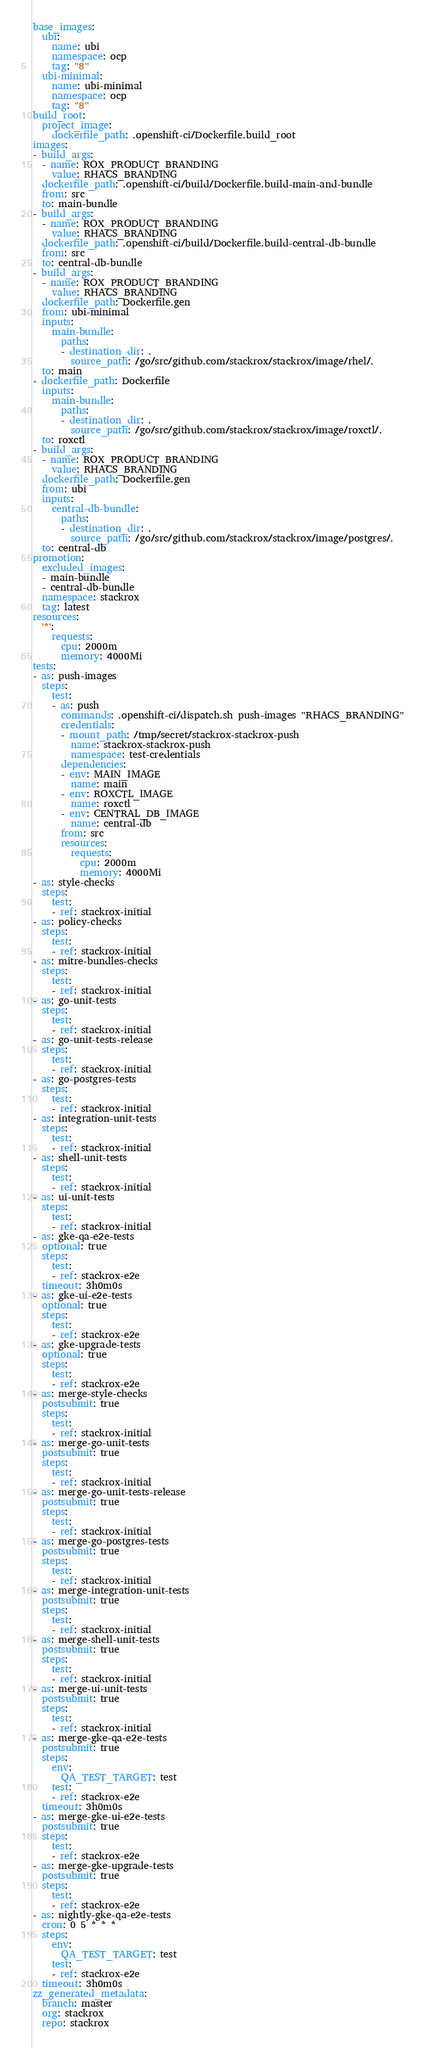Convert code to text. <code><loc_0><loc_0><loc_500><loc_500><_YAML_>base_images:
  ubi:
    name: ubi
    namespace: ocp
    tag: "8"
  ubi-minimal:
    name: ubi-minimal
    namespace: ocp
    tag: "8"
build_root:
  project_image:
    dockerfile_path: .openshift-ci/Dockerfile.build_root
images:
- build_args:
  - name: ROX_PRODUCT_BRANDING
    value: RHACS_BRANDING
  dockerfile_path: .openshift-ci/build/Dockerfile.build-main-and-bundle
  from: src
  to: main-bundle
- build_args:
  - name: ROX_PRODUCT_BRANDING
    value: RHACS_BRANDING
  dockerfile_path: .openshift-ci/build/Dockerfile.build-central-db-bundle
  from: src
  to: central-db-bundle
- build_args:
  - name: ROX_PRODUCT_BRANDING
    value: RHACS_BRANDING
  dockerfile_path: Dockerfile.gen
  from: ubi-minimal
  inputs:
    main-bundle:
      paths:
      - destination_dir: .
        source_path: /go/src/github.com/stackrox/stackrox/image/rhel/.
  to: main
- dockerfile_path: Dockerfile
  inputs:
    main-bundle:
      paths:
      - destination_dir: .
        source_path: /go/src/github.com/stackrox/stackrox/image/roxctl/.
  to: roxctl
- build_args:
  - name: ROX_PRODUCT_BRANDING
    value: RHACS_BRANDING
  dockerfile_path: Dockerfile.gen
  from: ubi
  inputs:
    central-db-bundle:
      paths:
      - destination_dir: .
        source_path: /go/src/github.com/stackrox/stackrox/image/postgres/.
  to: central-db
promotion:
  excluded_images:
  - main-bundle
  - central-db-bundle
  namespace: stackrox
  tag: latest
resources:
  '*':
    requests:
      cpu: 2000m
      memory: 4000Mi
tests:
- as: push-images
  steps:
    test:
    - as: push
      commands: .openshift-ci/dispatch.sh push-images "RHACS_BRANDING"
      credentials:
      - mount_path: /tmp/secret/stackrox-stackrox-push
        name: stackrox-stackrox-push
        namespace: test-credentials
      dependencies:
      - env: MAIN_IMAGE
        name: main
      - env: ROXCTL_IMAGE
        name: roxctl
      - env: CENTRAL_DB_IMAGE
        name: central-db
      from: src
      resources:
        requests:
          cpu: 2000m
          memory: 4000Mi
- as: style-checks
  steps:
    test:
    - ref: stackrox-initial
- as: policy-checks
  steps:
    test:
    - ref: stackrox-initial
- as: mitre-bundles-checks
  steps:
    test:
    - ref: stackrox-initial
- as: go-unit-tests
  steps:
    test:
    - ref: stackrox-initial
- as: go-unit-tests-release
  steps:
    test:
    - ref: stackrox-initial
- as: go-postgres-tests
  steps:
    test:
    - ref: stackrox-initial
- as: integration-unit-tests
  steps:
    test:
    - ref: stackrox-initial
- as: shell-unit-tests
  steps:
    test:
    - ref: stackrox-initial
- as: ui-unit-tests
  steps:
    test:
    - ref: stackrox-initial
- as: gke-qa-e2e-tests
  optional: true
  steps:
    test:
    - ref: stackrox-e2e
  timeout: 3h0m0s
- as: gke-ui-e2e-tests
  optional: true
  steps:
    test:
    - ref: stackrox-e2e
- as: gke-upgrade-tests
  optional: true
  steps:
    test:
    - ref: stackrox-e2e
- as: merge-style-checks
  postsubmit: true
  steps:
    test:
    - ref: stackrox-initial
- as: merge-go-unit-tests
  postsubmit: true
  steps:
    test:
    - ref: stackrox-initial
- as: merge-go-unit-tests-release
  postsubmit: true
  steps:
    test:
    - ref: stackrox-initial
- as: merge-go-postgres-tests
  postsubmit: true
  steps:
    test:
    - ref: stackrox-initial
- as: merge-integration-unit-tests
  postsubmit: true
  steps:
    test:
    - ref: stackrox-initial
- as: merge-shell-unit-tests
  postsubmit: true
  steps:
    test:
    - ref: stackrox-initial
- as: merge-ui-unit-tests
  postsubmit: true
  steps:
    test:
    - ref: stackrox-initial
- as: merge-gke-qa-e2e-tests
  postsubmit: true
  steps:
    env:
      QA_TEST_TARGET: test
    test:
    - ref: stackrox-e2e
  timeout: 3h0m0s
- as: merge-gke-ui-e2e-tests
  postsubmit: true
  steps:
    test:
    - ref: stackrox-e2e
- as: merge-gke-upgrade-tests
  postsubmit: true
  steps:
    test:
    - ref: stackrox-e2e
- as: nightly-gke-qa-e2e-tests
  cron: 0 5 * * *
  steps:
    env:
      QA_TEST_TARGET: test
    test:
    - ref: stackrox-e2e
  timeout: 3h0m0s
zz_generated_metadata:
  branch: master
  org: stackrox
  repo: stackrox
</code> 